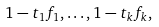<formula> <loc_0><loc_0><loc_500><loc_500>1 - t _ { 1 } f _ { 1 } , \dots , 1 - t _ { k } f _ { k } ,</formula> 